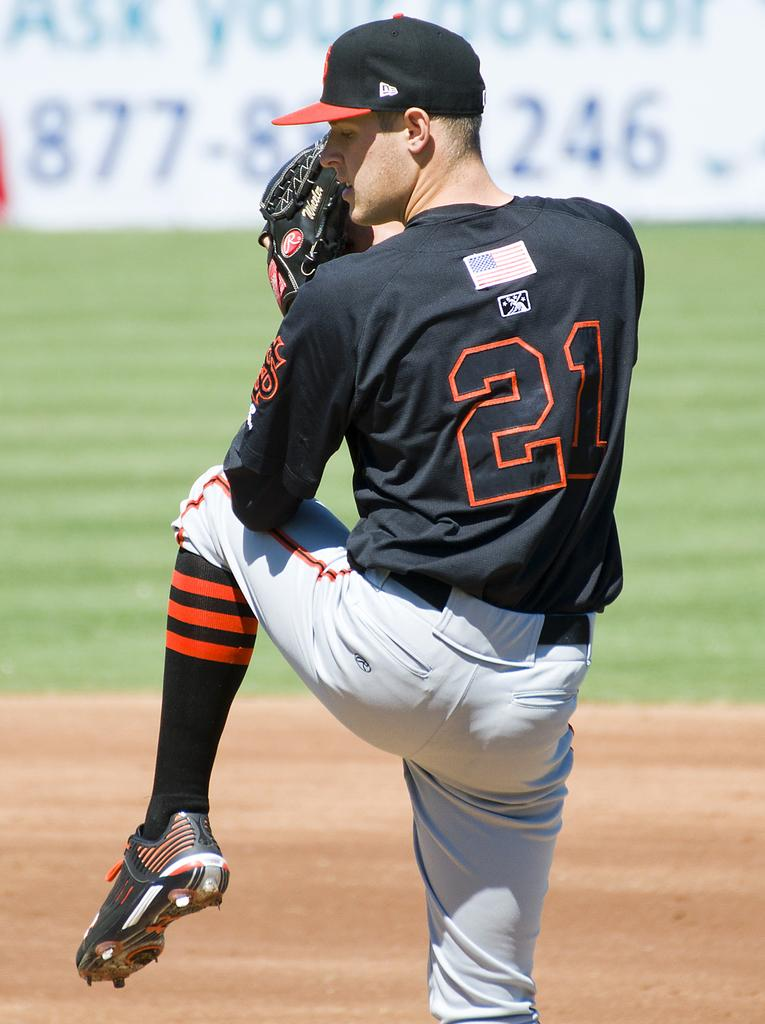<image>
Describe the image concisely. Baseball player number 21 with an ask your doctor advertisement behind him. 